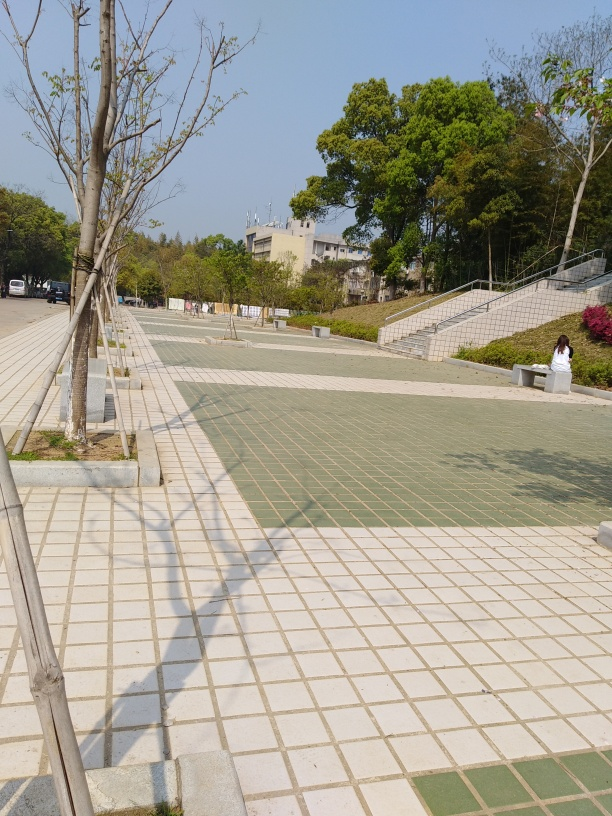Can you tell me more about the area captured in this image? The image shows a spacious outdoor area with pedestrian paths, stairs, and lined with trees. It appears to be a well-maintained public space, possibly part of a park or campus, that facilitates both leisure and transit. The clear skies and the presence of greenery suggest a serene atmosphere, appropriate for relaxation or casual strolls. What's the best way to improve the composition of this image? To improve the composition, the photographer could apply the rule of thirds by adjusting the camera angle to position key elements like the stairs and the treeline along the intersecting lines, creating more interest and balance. Removing or reducing shadows, perhaps by choosing a different time of day or angle to capture the shot, would also improve visual appeal. 